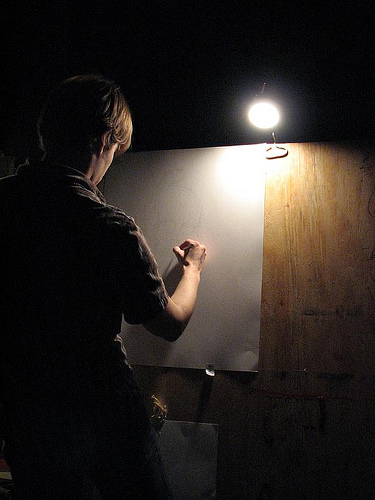<image>
Is the wall in front of the light? No. The wall is not in front of the light. The spatial positioning shows a different relationship between these objects. 